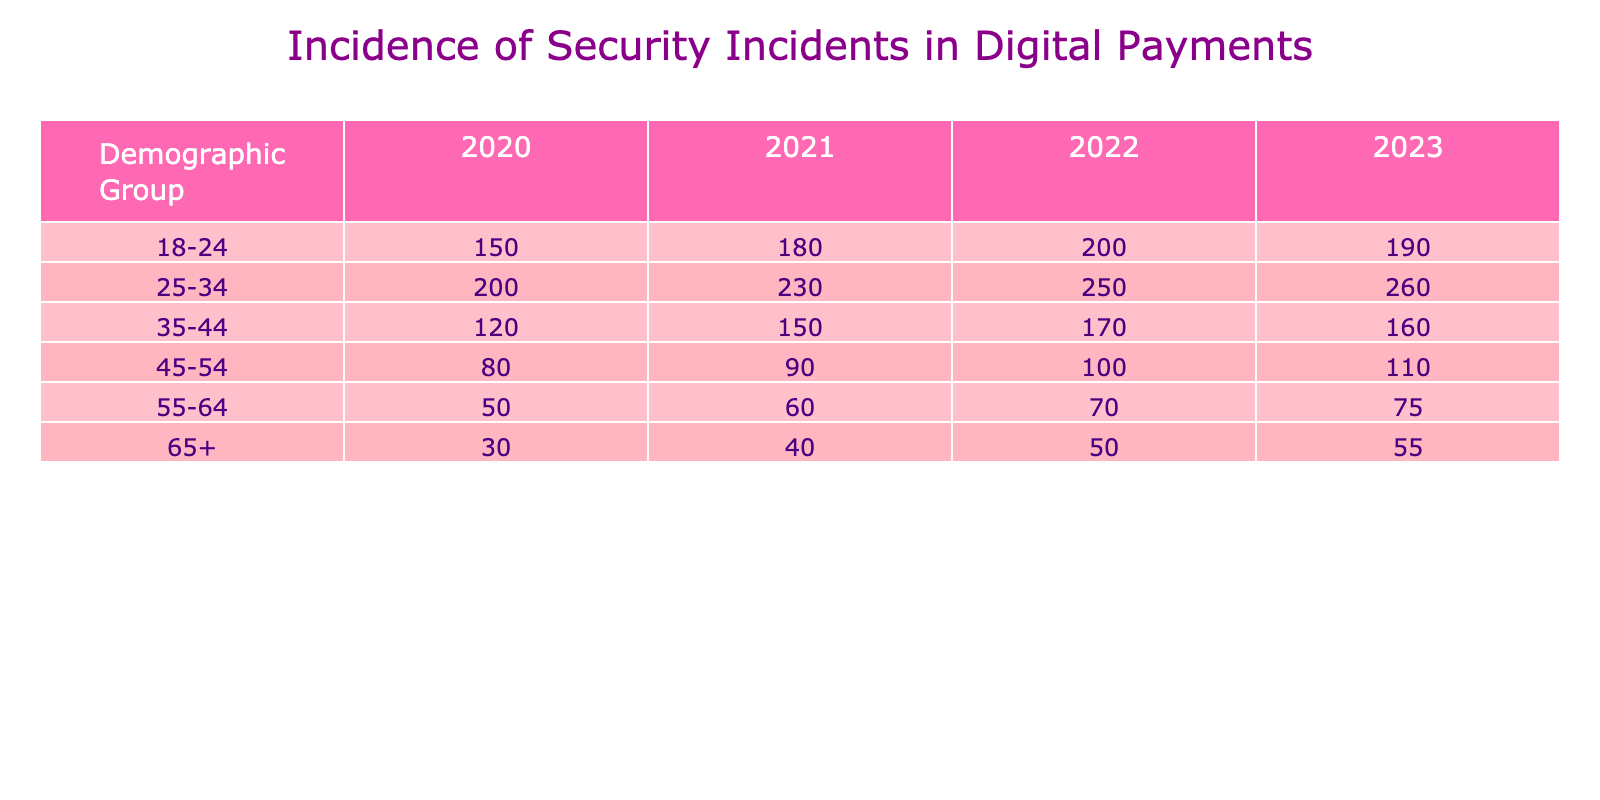What was the incidence of security incidents in 2021 for the 25-34 age group? The table shows that in 2021, the incidence of security incidents for the 25-34 age group is directly listed under the 2021 column for that demographic, which is 230.
Answer: 230 Which demographic group had the highest incidence of security incidents in 2022? By scanning through the 2022 column, the 25-34 age group has the highest count, with 250 security incidents, compared to other groups listed in that year.
Answer: 25-34 What is the total incidence of security incidents across all groups in 2020? To find the total for 2020, we sum the values in the corresponding row: 150 (18-24) + 200 (25-34) + 120 (35-44) + 80 (45-54) + 50 (55-64) + 30 (65+) = 630.
Answer: 630 Is it true that the incidence of security incidents decreased for the 55-64 age group from 2021 to 2022? Looking at the values for the 55-64 age group, in 2021 it was 60 incidents, and in 2022 it decreased to 70. This indicates an increase, so the statement is false.
Answer: No What was the average incidence of security incidents for the 65+ age group across all years? We take the values from each year for the 65+ group: 30 (2020) + 40 (2021) + 50 (2022) + 55 (2023) = 175. There are 4 years, so we divide 175 by 4, giving us an average of 43.75.
Answer: 43.75 Which year had the lowest incidence of security incidents for the 45-54 age group? Checking the row for the 45-54 age group across the years, the values are 80 (2020), 90 (2021), 100 (2022), and 110 (2023). The lowest is clearly 80 in 2020.
Answer: 2020 How many more incidents were reported in 2023 for the 18-24 age group compared to 2020? For the 18-24 group in 2023, there were 190 incidents, and in 2020 there were 150 incidents. The difference is 190 - 150 = 40 more incidents in 2023.
Answer: 40 What is the percentage increase in incidents for the 25-34 age group from 2020 to 2023? The number of incidents in 2020 was 200 and in 2023 it is 260. The increase is 260 - 200 = 60. To find the percentage increase: (60 / 200) * 100 = 30%.
Answer: 30% 